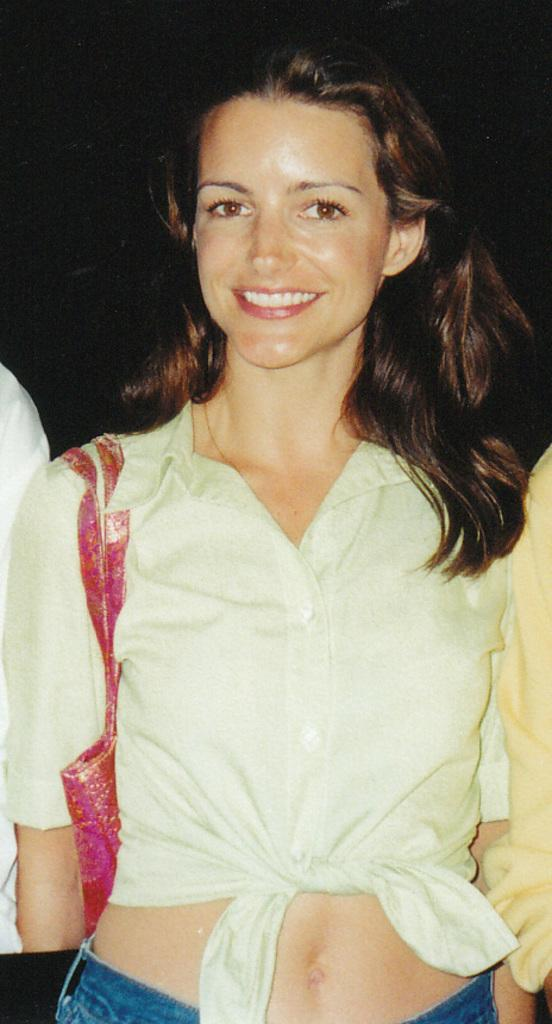Who is present in the image? There is a woman in the image. What is the woman wearing? The woman is wearing a white dress and a bag. What is the woman's facial expression? The woman is smiling. Can you describe the background of the image? The background of the image is dark. What type of business does the doctor run in the image? There is no doctor or business present in the image; it features a woman wearing a white dress and a bag. How many bikes are visible in the image? There are no bikes present in the image. 